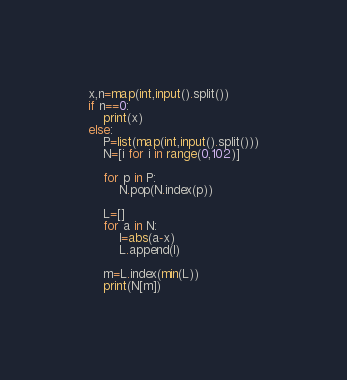<code> <loc_0><loc_0><loc_500><loc_500><_Python_>x,n=map(int,input().split())
if n==0:
    print(x)
else:
    P=list(map(int,input().split()))
    N=[i for i in range(0,102)]

    for p in P:
        N.pop(N.index(p))

    L=[]
    for a in N:
        l=abs(a-x)
        L.append(l)
    
    m=L.index(min(L))
    print(N[m])</code> 